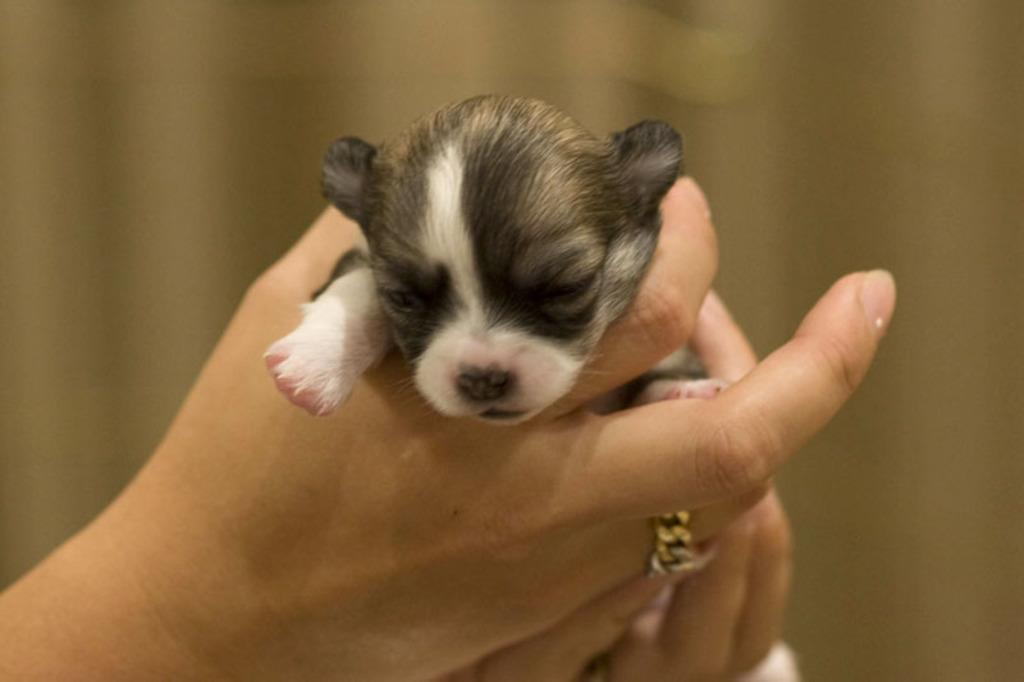What is being held by the human hands in the image? There are human hands holding a puppy in the image. Can you describe the appearance of the puppy? The puppy is black, brown, and white in color. How would you describe the background of the image? The background of the image is blurry and brown in color. What type of tax is being discussed by the boys in the image? There are no boys present in the image, and no tax-related discussion is taking place. 